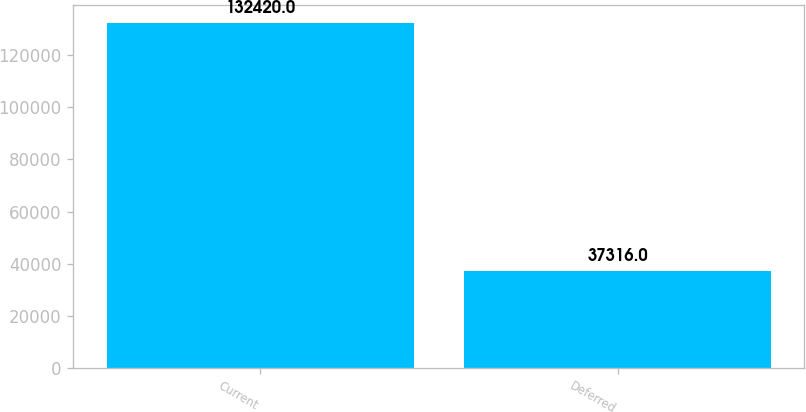<chart> <loc_0><loc_0><loc_500><loc_500><bar_chart><fcel>Current<fcel>Deferred<nl><fcel>132420<fcel>37316<nl></chart> 